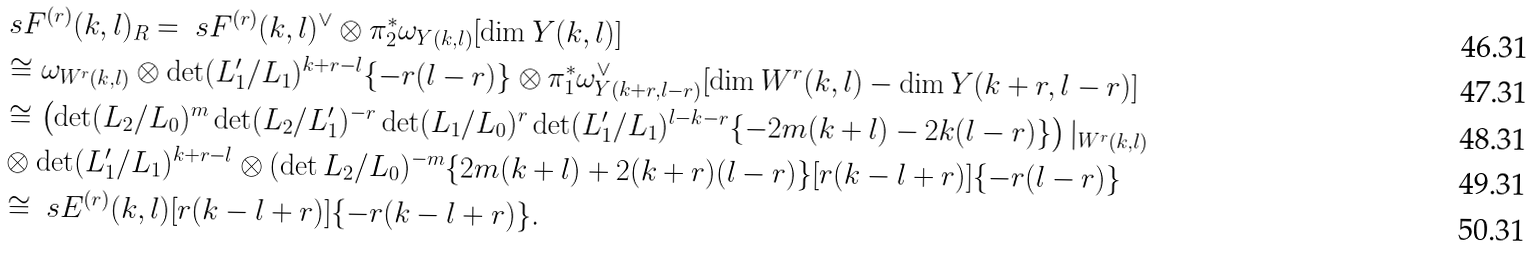<formula> <loc_0><loc_0><loc_500><loc_500>& \ s F ^ { ( r ) } ( k , l ) _ { R } = \ s F ^ { ( r ) } ( k , l ) ^ { \vee } \otimes \pi _ { 2 } ^ { * } \omega _ { Y ( k , l ) } [ \dim Y ( k , l ) ] \\ & \cong \omega _ { W ^ { r } ( k , l ) } \otimes \det ( L _ { 1 } ^ { \prime } / L _ { 1 } ) ^ { k + r - l } \{ - r ( l - r ) \} \otimes \pi _ { 1 } ^ { * } \omega _ { Y ( k + r , l - r ) } ^ { \vee } [ \dim W ^ { r } ( k , l ) - \dim Y ( k + r , l - r ) ] \\ & \cong \left ( \det ( L _ { 2 } / L _ { 0 } ) ^ { m } \det ( L _ { 2 } / L _ { 1 } ^ { \prime } ) ^ { - r } \det ( L _ { 1 } / L _ { 0 } ) ^ { r } \det ( L _ { 1 } ^ { \prime } / L _ { 1 } ) ^ { l - k - r } \{ - 2 m ( k + l ) - 2 k ( l - r ) \} \right ) | _ { W ^ { r } ( k , l ) } \\ & \otimes \det ( L _ { 1 } ^ { \prime } / L _ { 1 } ) ^ { k + r - l } \otimes ( \det L _ { 2 } / L _ { 0 } ) ^ { - m } \{ 2 m ( k + l ) + 2 ( k + r ) ( l - r ) \} [ r ( k - l + r ) ] \{ - r ( l - r ) \} \\ & \cong \ s E ^ { ( r ) } ( k , l ) [ r ( k - l + r ) ] \{ - r ( k - l + r ) \} .</formula> 